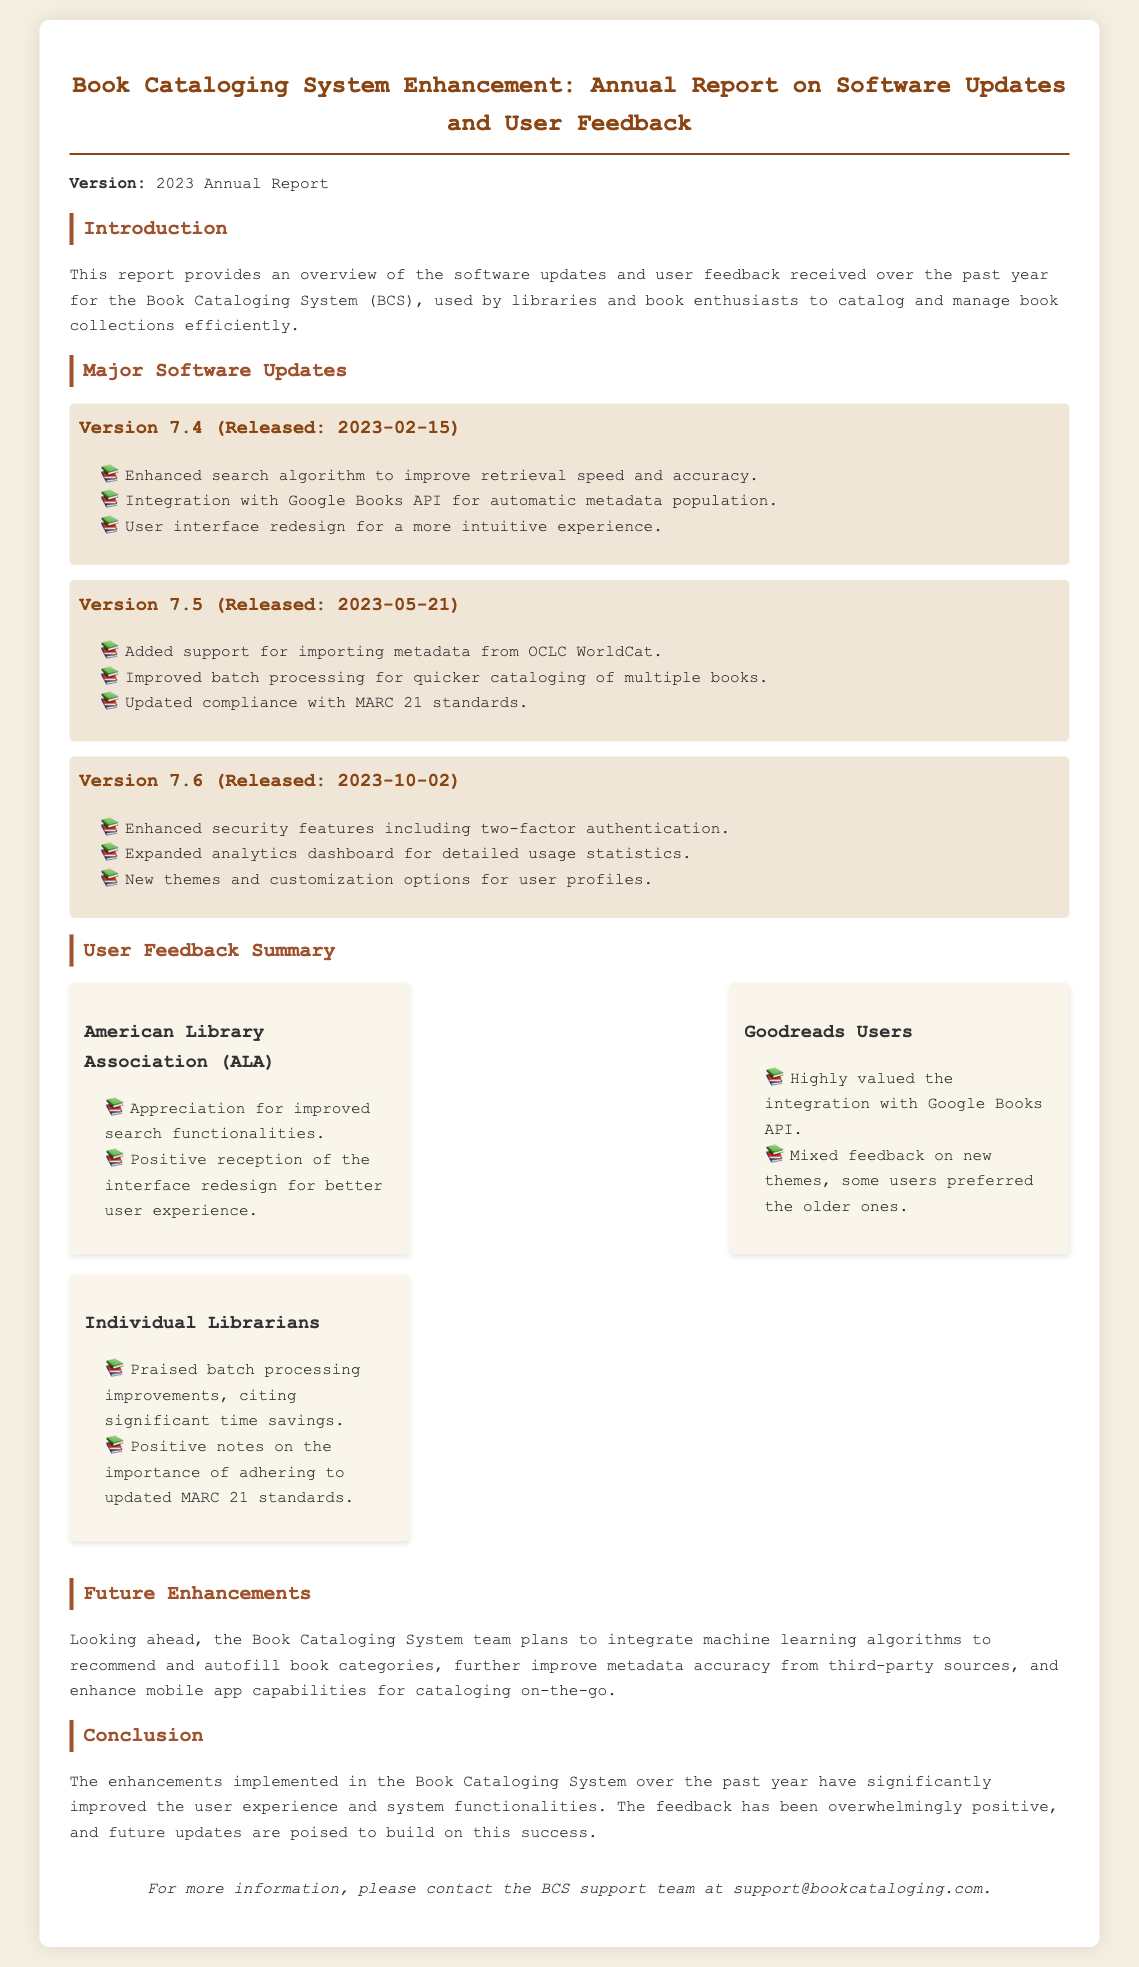What is the version of the report? The version of the report is stated at the beginning of the document.
Answer: 2023 Annual Report When was Version 7.4 released? The release date for Version 7.4 is mentioned alongside the version information.
Answer: 2023-02-15 What API is integrated for automatic metadata population? The document specifies a particular API used for metadata.
Answer: Google Books API Which feature emphasizes security in Version 7.6? Version 7.6 highlights a specific security feature.
Answer: Two-factor authentication Which organization praised the improved search functionalities? The document lists various feedback providers, indicating who praised the search functionalities.
Answer: American Library Association (ALA) What was the user reception for the new themes? The user feedback regarding the new themes is mentioned in the document, indicating their reception.
Answer: Mixed feedback What significant improvement did individual librarians praise? The document highlights a specific improvement praised by individual librarians.
Answer: Batch processing improvements What future enhancement involves machine learning? The document outlines a planned enhancement related to machine learning.
Answer: Recommend and autofill book categories 